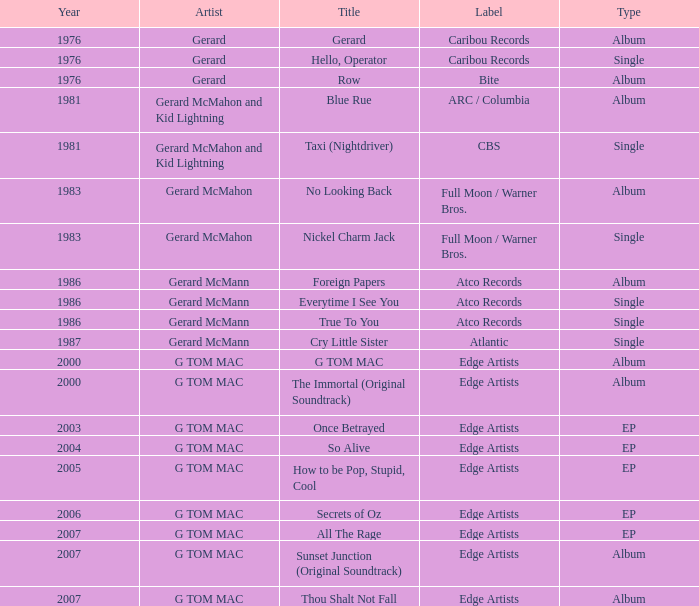Which Title has a Type of album and a Year larger than 1986? G TOM MAC, The Immortal (Original Soundtrack), Sunset Junction (Original Soundtrack), Thou Shalt Not Fall. 